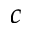<formula> <loc_0><loc_0><loc_500><loc_500>c</formula> 